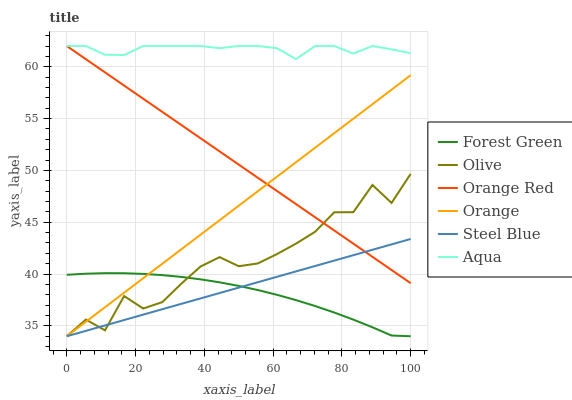Does Steel Blue have the minimum area under the curve?
Answer yes or no. No. Does Steel Blue have the maximum area under the curve?
Answer yes or no. No. Is Orange the smoothest?
Answer yes or no. No. Is Orange the roughest?
Answer yes or no. No. Does Orange Red have the lowest value?
Answer yes or no. No. Does Steel Blue have the highest value?
Answer yes or no. No. Is Forest Green less than Orange Red?
Answer yes or no. Yes. Is Orange Red greater than Forest Green?
Answer yes or no. Yes. Does Forest Green intersect Orange Red?
Answer yes or no. No. 